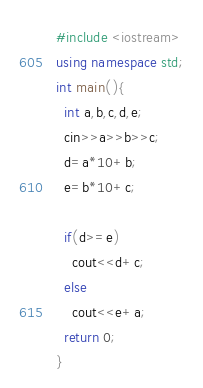<code> <loc_0><loc_0><loc_500><loc_500><_C++_>#include <iostream>
using namespace std;
int main(){
  int a,b,c,d,e;
  cin>>a>>b>>c;
  d=a*10+b;
  e=b*10+c;
  
  if(d>=e)
    cout<<d+c;
  else 
    cout<<e+a;
  return 0;
}</code> 